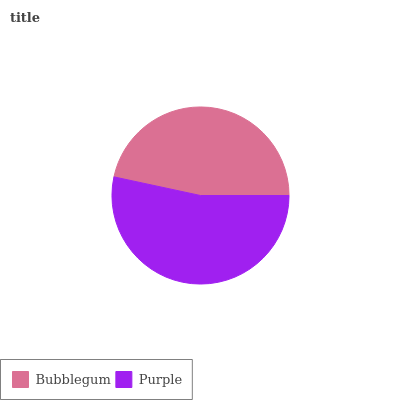Is Bubblegum the minimum?
Answer yes or no. Yes. Is Purple the maximum?
Answer yes or no. Yes. Is Purple the minimum?
Answer yes or no. No. Is Purple greater than Bubblegum?
Answer yes or no. Yes. Is Bubblegum less than Purple?
Answer yes or no. Yes. Is Bubblegum greater than Purple?
Answer yes or no. No. Is Purple less than Bubblegum?
Answer yes or no. No. Is Purple the high median?
Answer yes or no. Yes. Is Bubblegum the low median?
Answer yes or no. Yes. Is Bubblegum the high median?
Answer yes or no. No. Is Purple the low median?
Answer yes or no. No. 